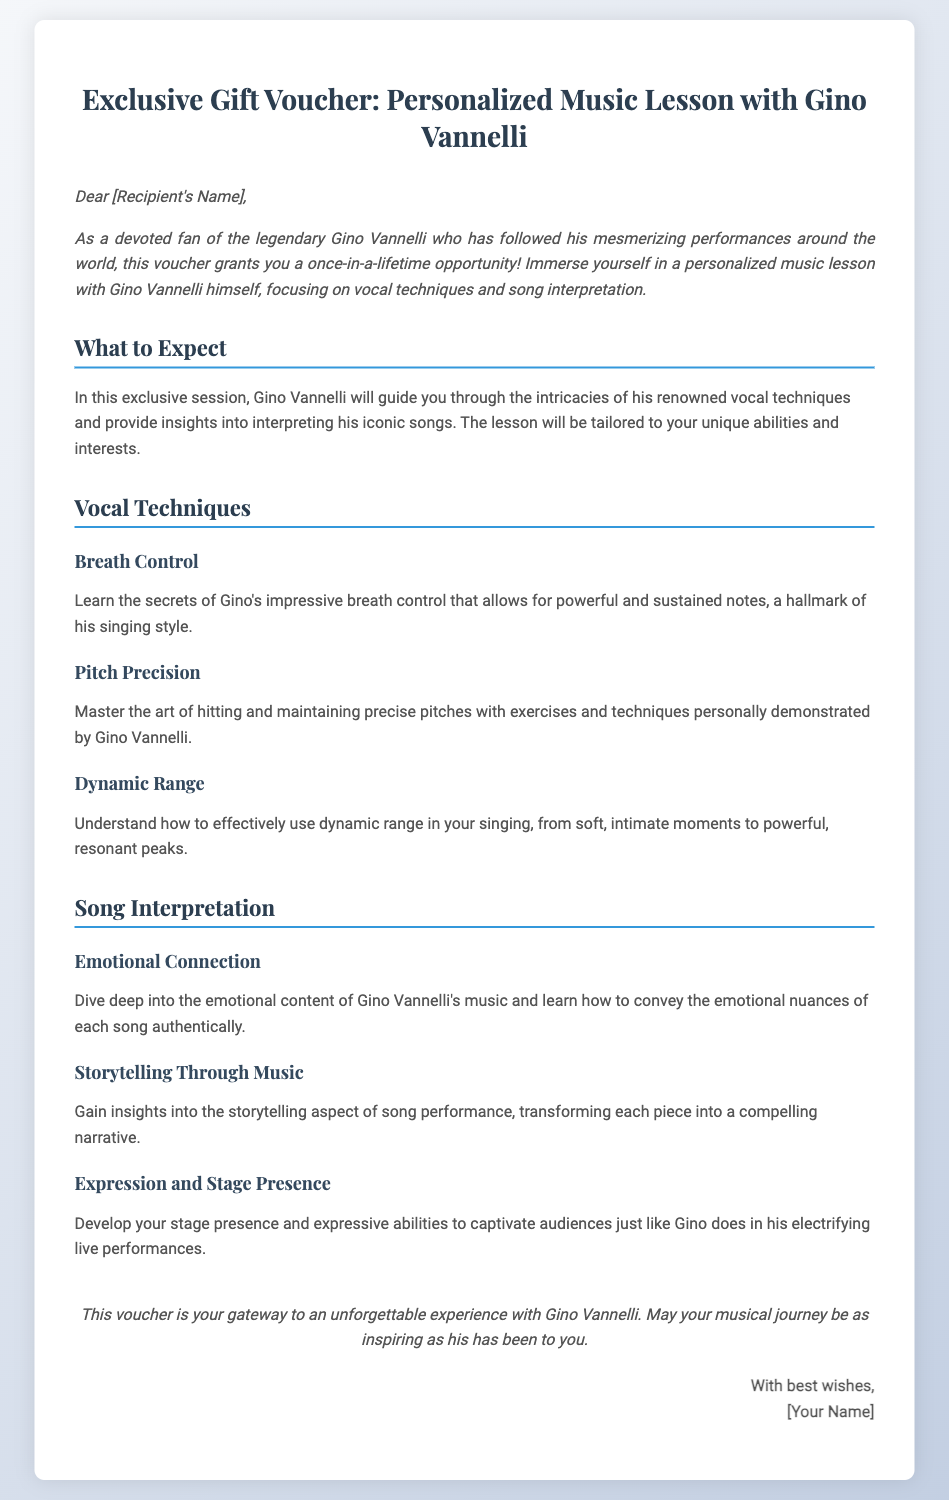What is the title of the voucher? The title of the voucher is presented at the top of the document.
Answer: Exclusive Gift Voucher: Personalized Music Lesson with Gino Vannelli Who is the recipient of the voucher addressed to? The recipient's name is mentioned in the introduction section of the voucher.
Answer: [Recipient's Name] What will Gino Vannelli focus on during the music lesson? The lesson's focus is outlined in the introduction and what to expect sections of the document.
Answer: Vocal techniques and song interpretation What is one of the vocal techniques that will be taught? The document lists several vocal techniques under the respective section.
Answer: Breath Control What aspect of song performance is highlighted in the emotional connection section? The emotional connection section emphasizes how to convey feelings in songs.
Answer: Emotional content What is the intended effect of learning about dynamic range? The section describes what understanding dynamic range will help improve in singing.
Answer: Powerful, resonant peaks What journey does the voucher mention for the recipient? The closing paragraph references a theme of inspiration tied to Gino Vannelli's journey.
Answer: Musical journey Who is the message in the signature from? The signature section identifies the sender of the gift voucher.
Answer: [Your Name] 